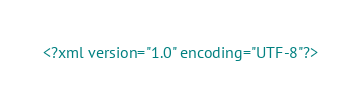Convert code to text. <code><loc_0><loc_0><loc_500><loc_500><_XML_><?xml version="1.0" encoding="UTF-8"?></code> 